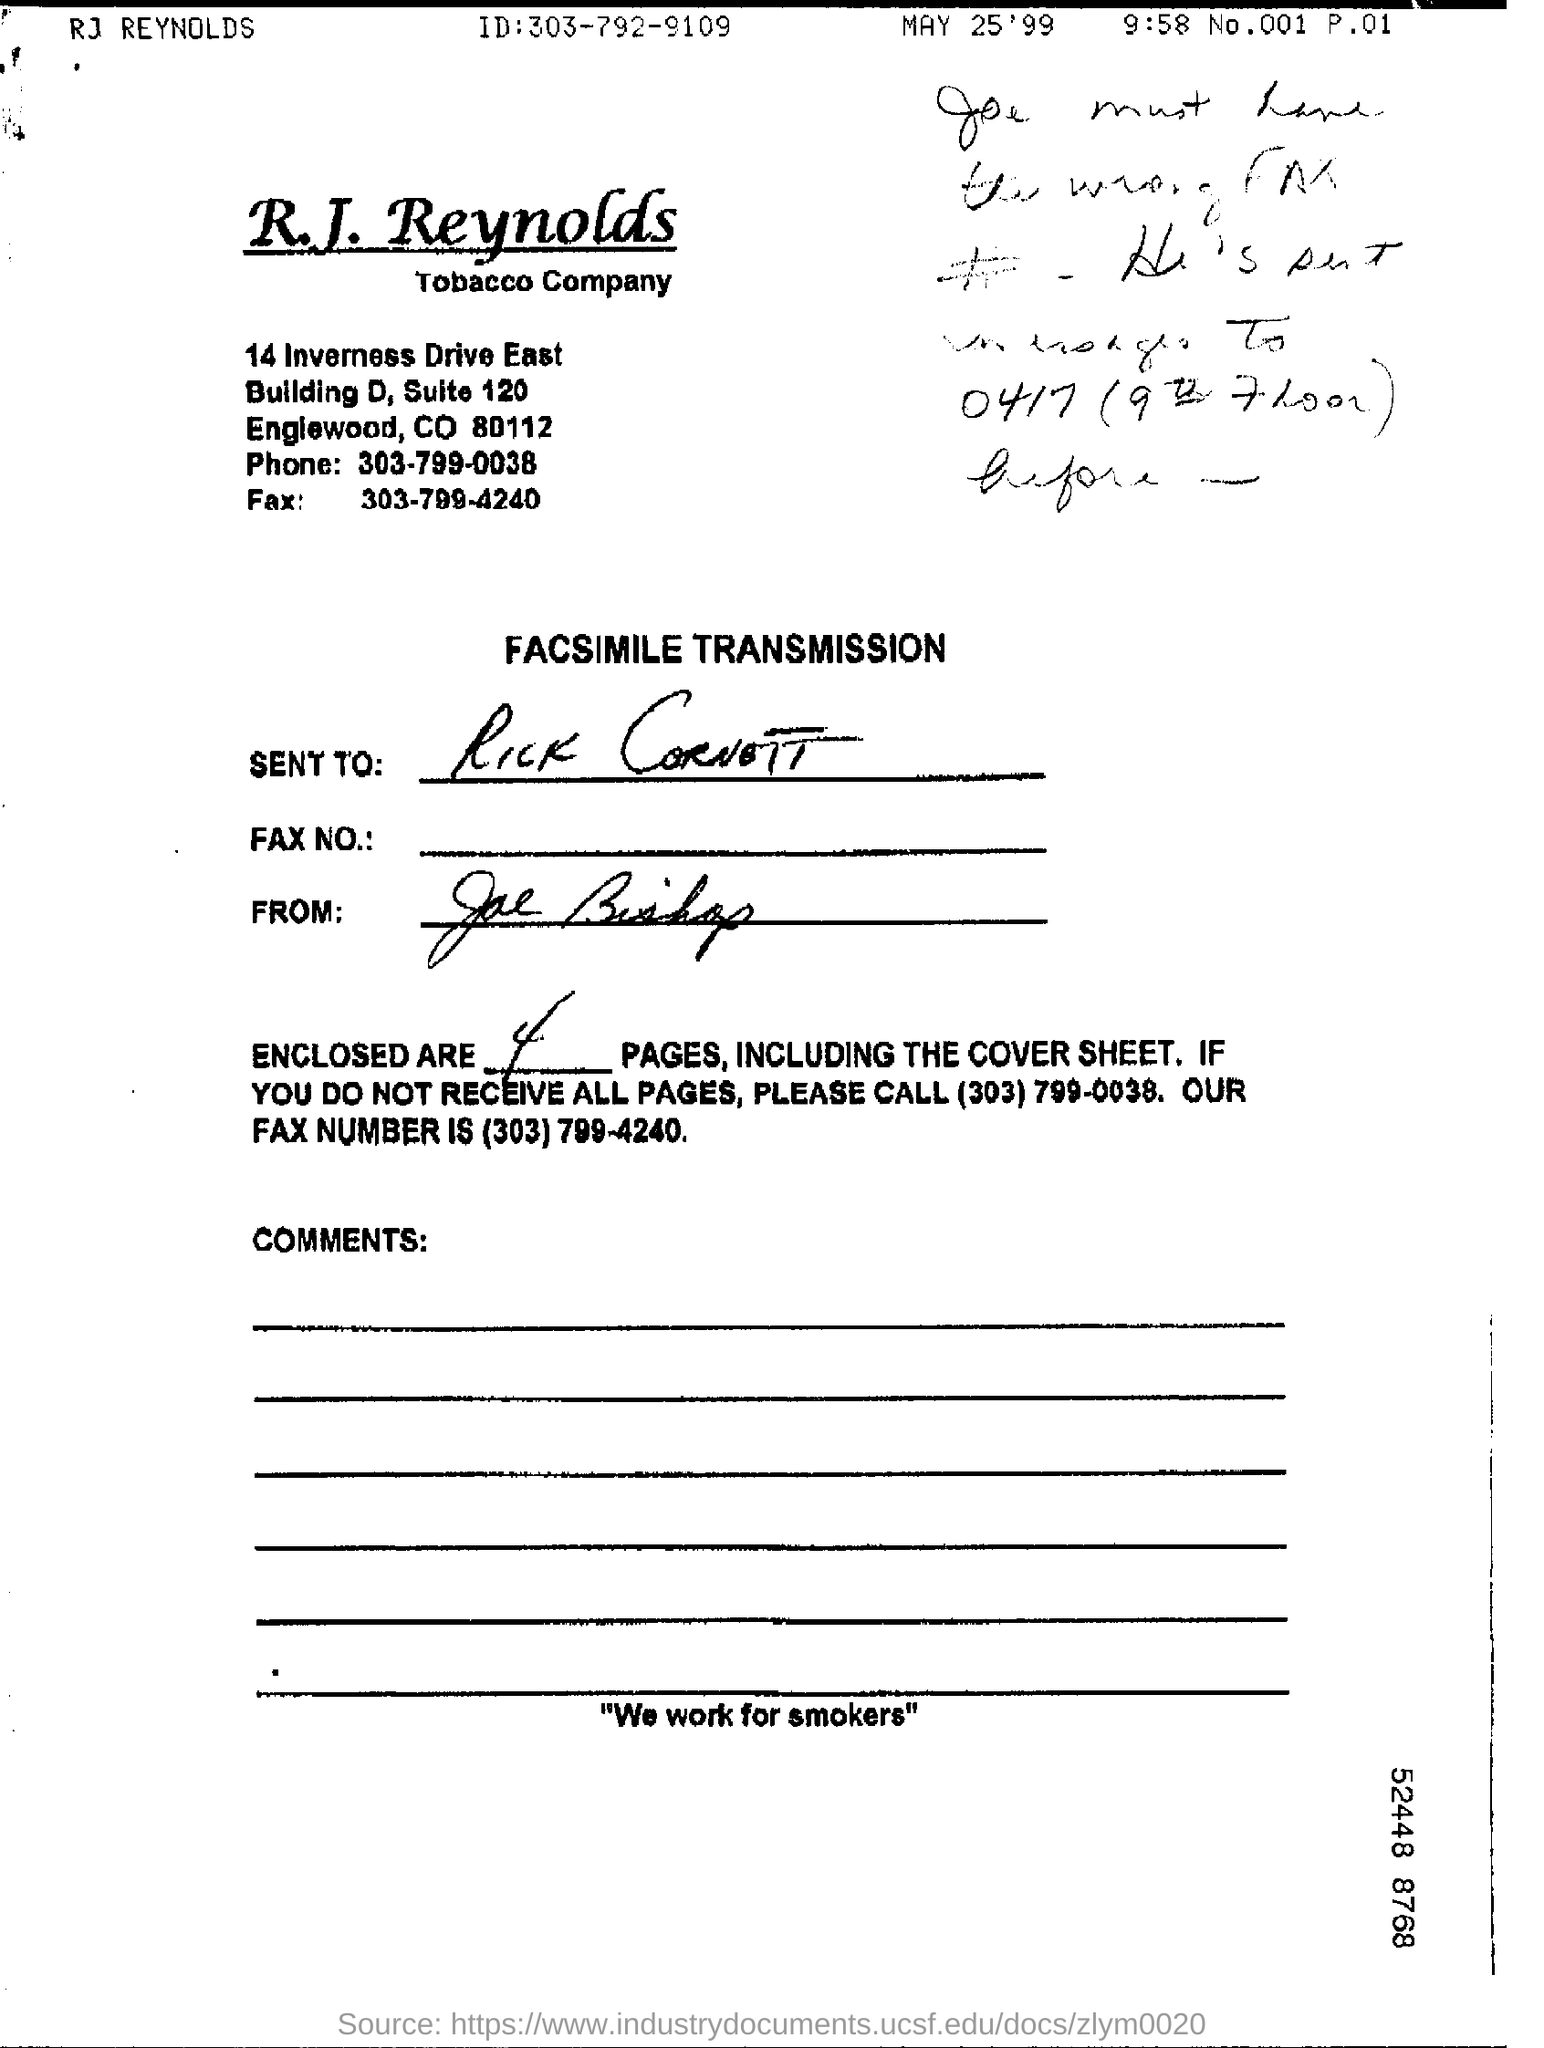Highlight a few significant elements in this photo. There are a total of 4 pages, including the cover sheet. The contact number for R.J. Reynolds is 303-799-0038. The name of a tobacco company is R.J. Reynolds. I am sending a facsimile transmission. 